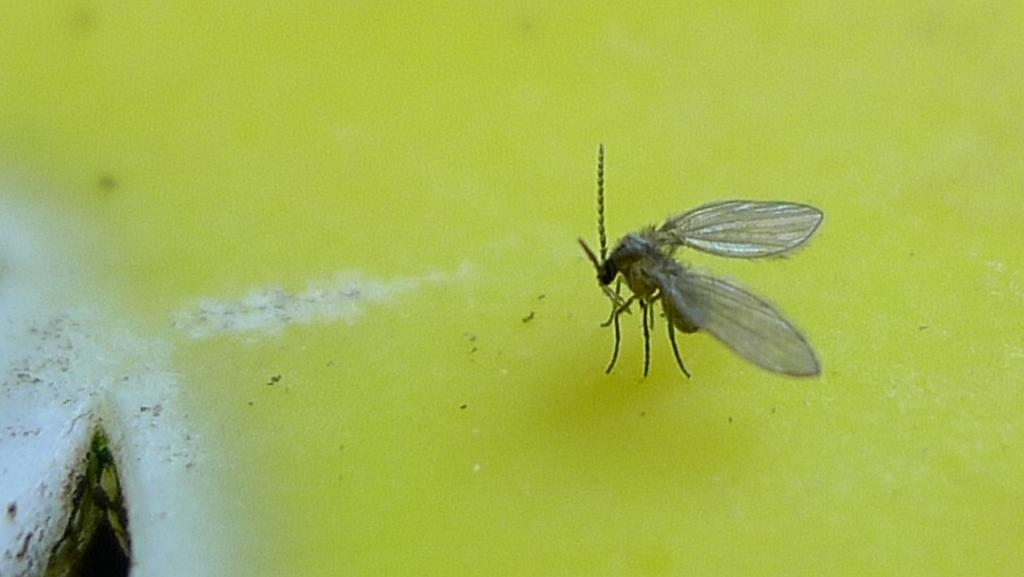What type of creature can be seen in the image? There is an insect in the image. Where is the insect located in the image? The insect is standing on the floor. What else can be seen on the floor in the image? There is some powder on the floor in the left bottom area of the image. What type of rhythm is the scarecrow playing in the image? There is no scarecrow or any musical instrument present in the image, so it is not possible to determine what rhythm might be played. 